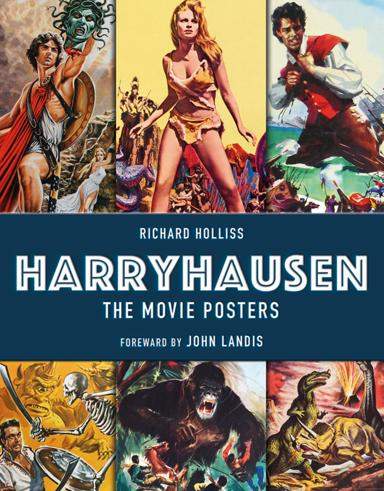What is the main topic of the book? The main topic of the book centers around the collection of movie posters from Ray Harryhausen's films. It offers a visual journey through the advertising and artistic representations that accompanied Harryhausen's groundbreaking visual effects in cinema. 